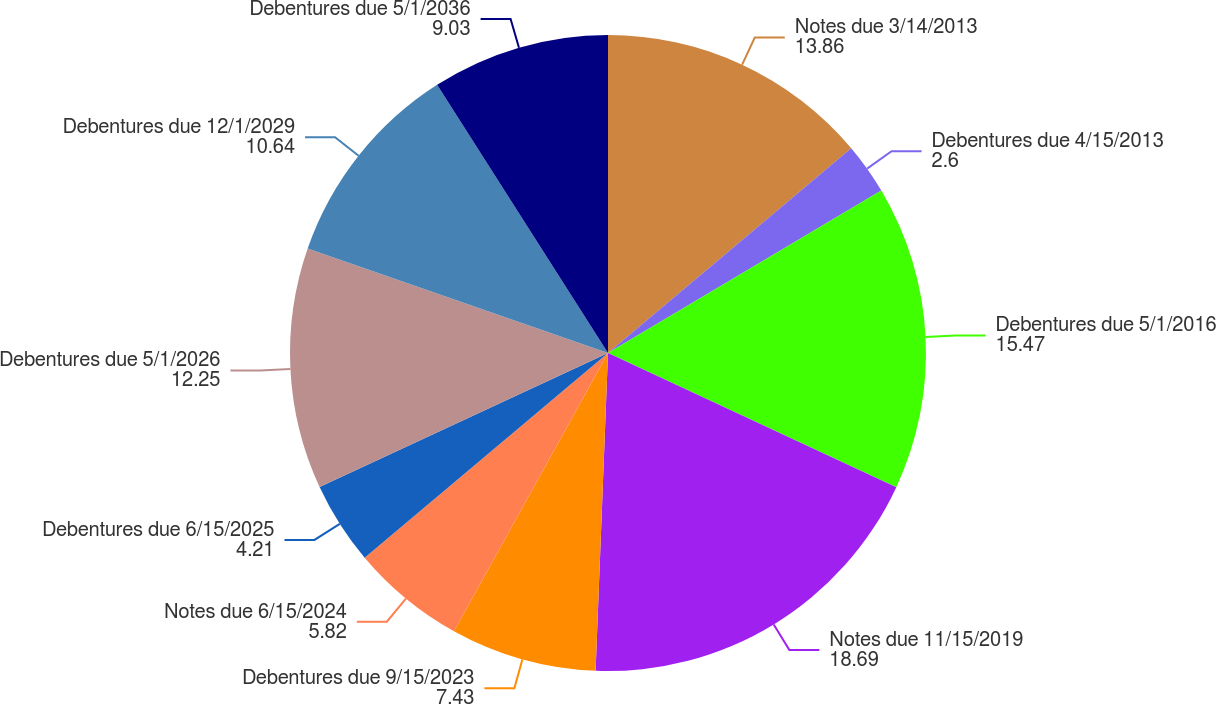Convert chart. <chart><loc_0><loc_0><loc_500><loc_500><pie_chart><fcel>Notes due 3/14/2013<fcel>Debentures due 4/15/2013<fcel>Debentures due 5/1/2016<fcel>Notes due 11/15/2019<fcel>Debentures due 9/15/2023<fcel>Notes due 6/15/2024<fcel>Debentures due 6/15/2025<fcel>Debentures due 5/1/2026<fcel>Debentures due 12/1/2029<fcel>Debentures due 5/1/2036<nl><fcel>13.86%<fcel>2.6%<fcel>15.47%<fcel>18.69%<fcel>7.43%<fcel>5.82%<fcel>4.21%<fcel>12.25%<fcel>10.64%<fcel>9.03%<nl></chart> 